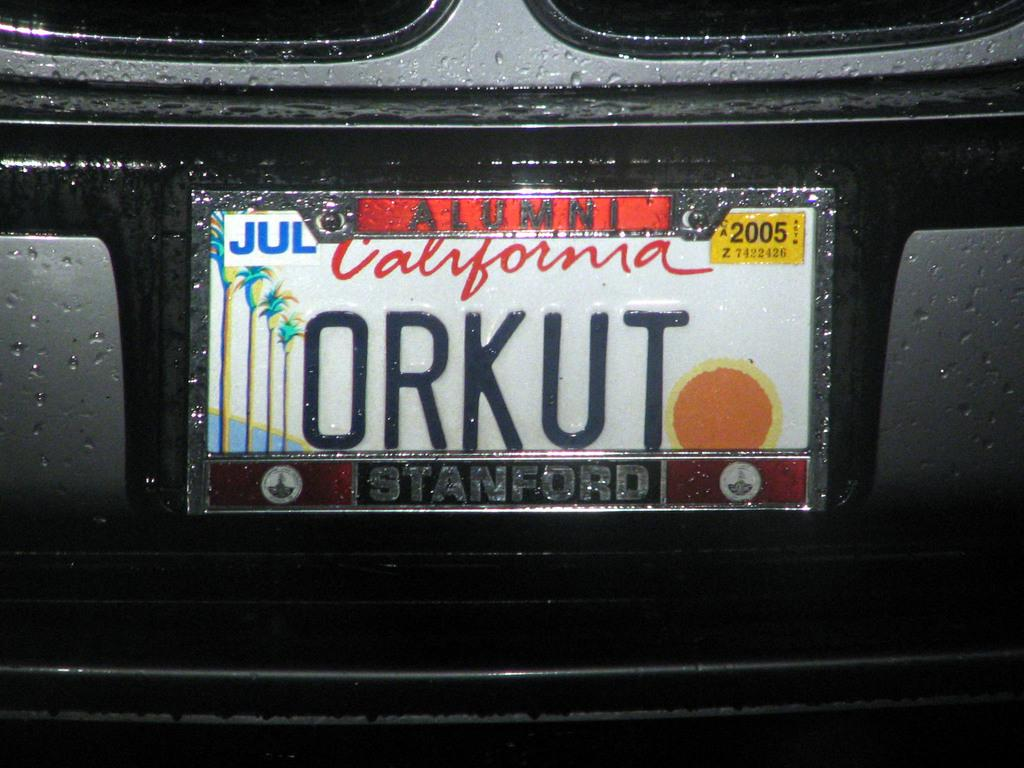<image>
Give a short and clear explanation of the subsequent image. White California license plate which says ORKUT on the back. 